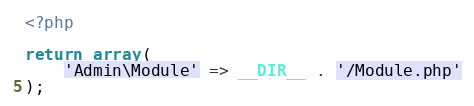<code> <loc_0><loc_0><loc_500><loc_500><_PHP_><?php

return array(
    'Admin\Module' => __DIR__ . '/Module.php'
);</code> 